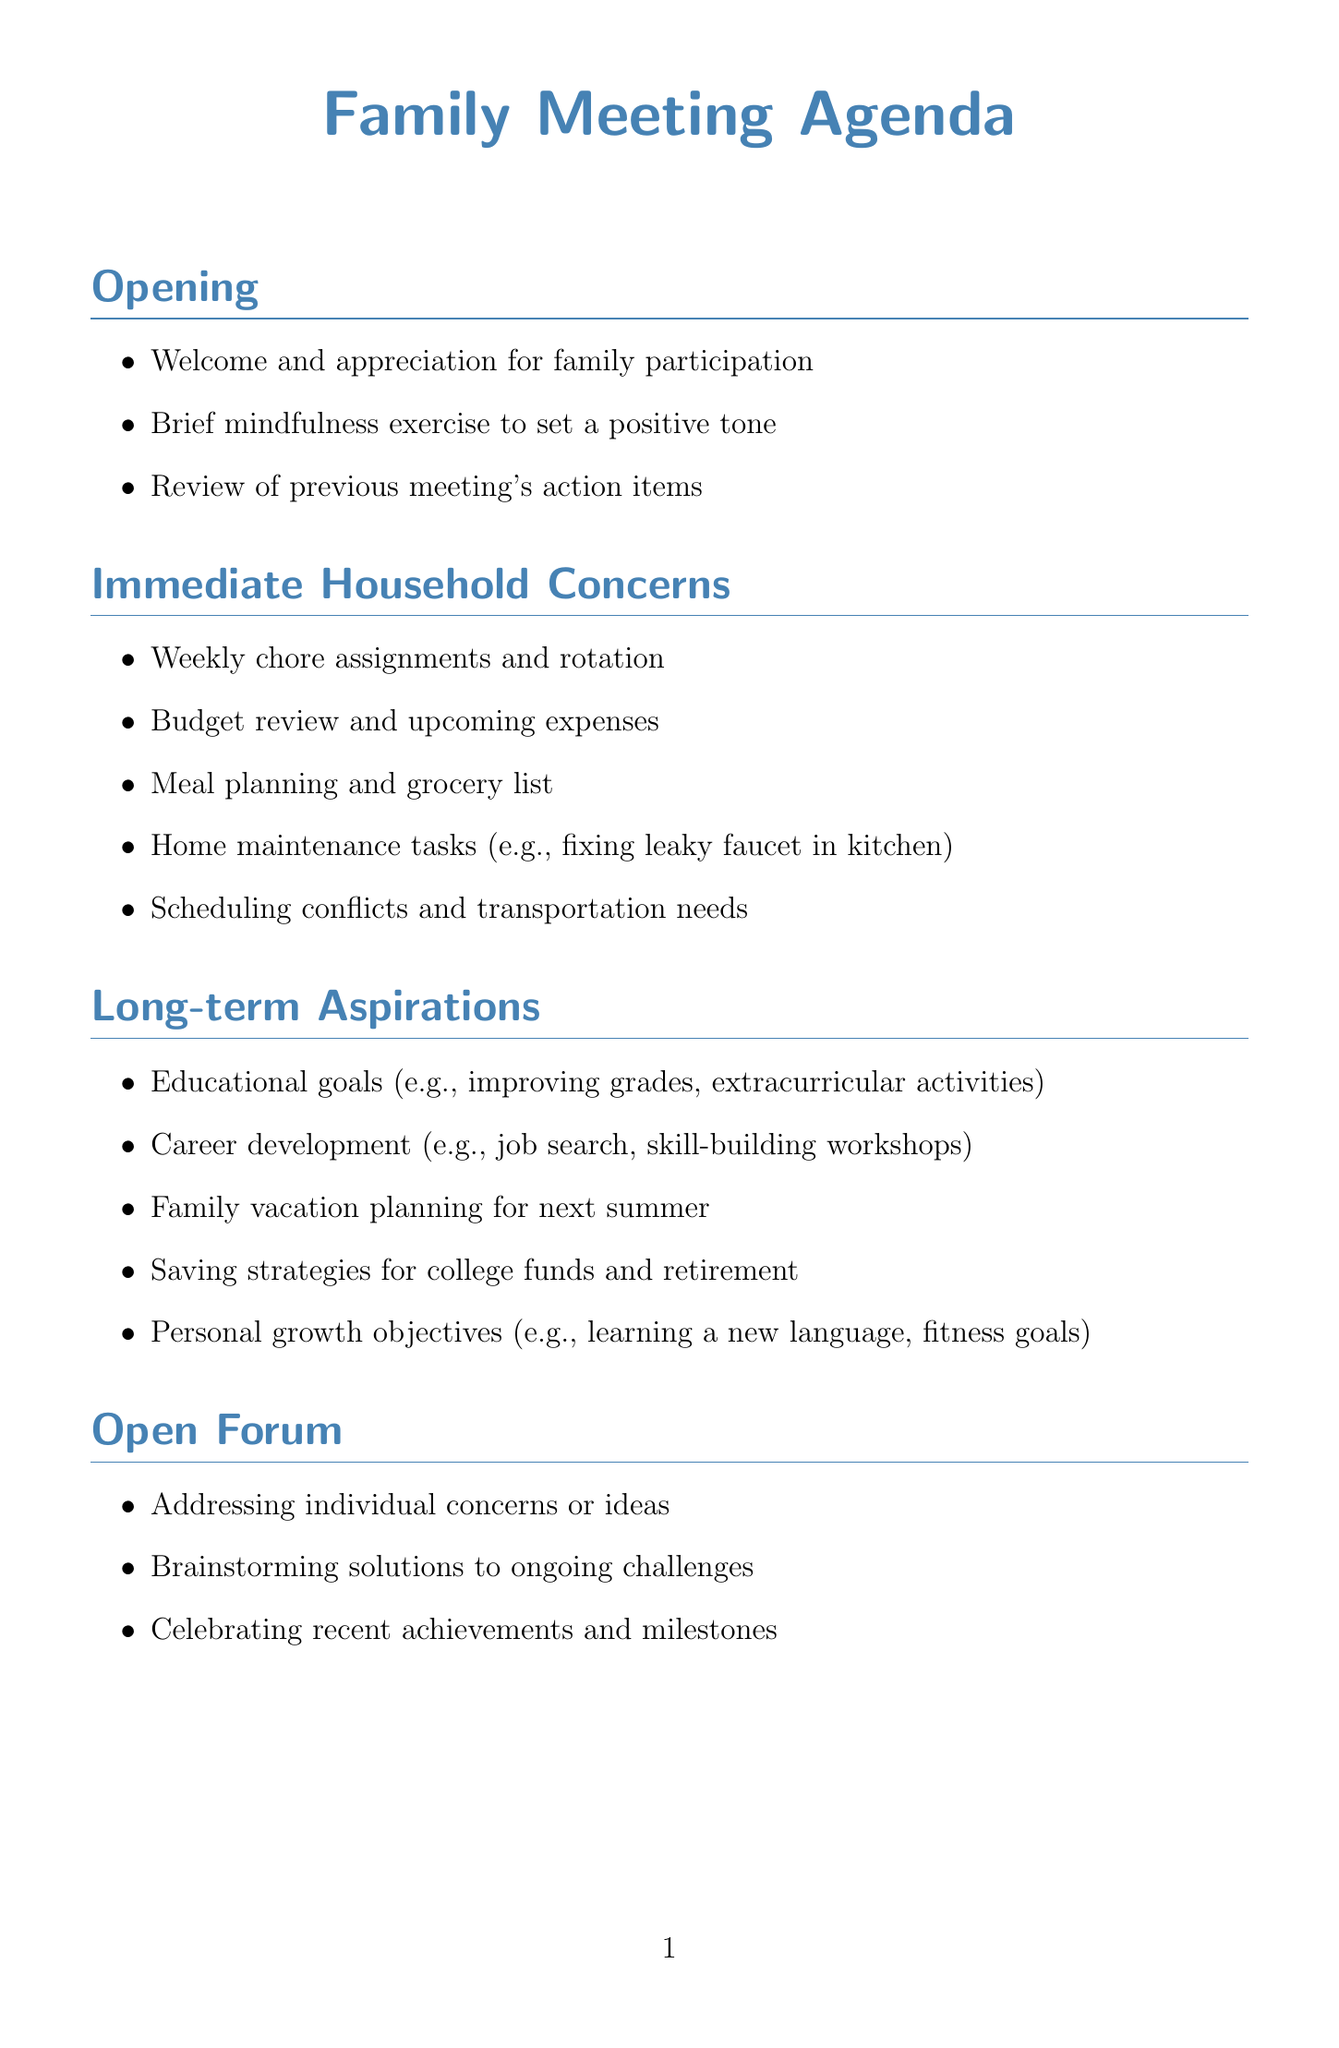What section addresses household tasks? The section that addresses household tasks is titled "Immediate Household Concerns."
Answer: Immediate Household Concerns How many items are listed under "Long-term Aspirations"? The number of items listed under "Long-term Aspirations" is five.
Answer: 5 What exercise is mentioned in the "Opening" section? The exercise mentioned in the "Opening" section is a "Brief mindfulness exercise to set a positive tone."
Answer: Brief mindfulness exercise What planning is mentioned for next summer? The planning mentioned for next summer includes "Family vacation planning."
Answer: Family vacation planning What is one of the items under "Practical Implementation"? One of the items under "Practical Implementation" is "Creating a family vision board for visual motivation."
Answer: Creating a family vision board Which section allows for individual concerns to be addressed? The section that allows for individual concerns to be addressed is the "Open Forum."
Answer: Open Forum How will the next family meeting be determined? The next family meeting will be scheduled during the "Closing" section.
Answer: Schedule next family meeting 